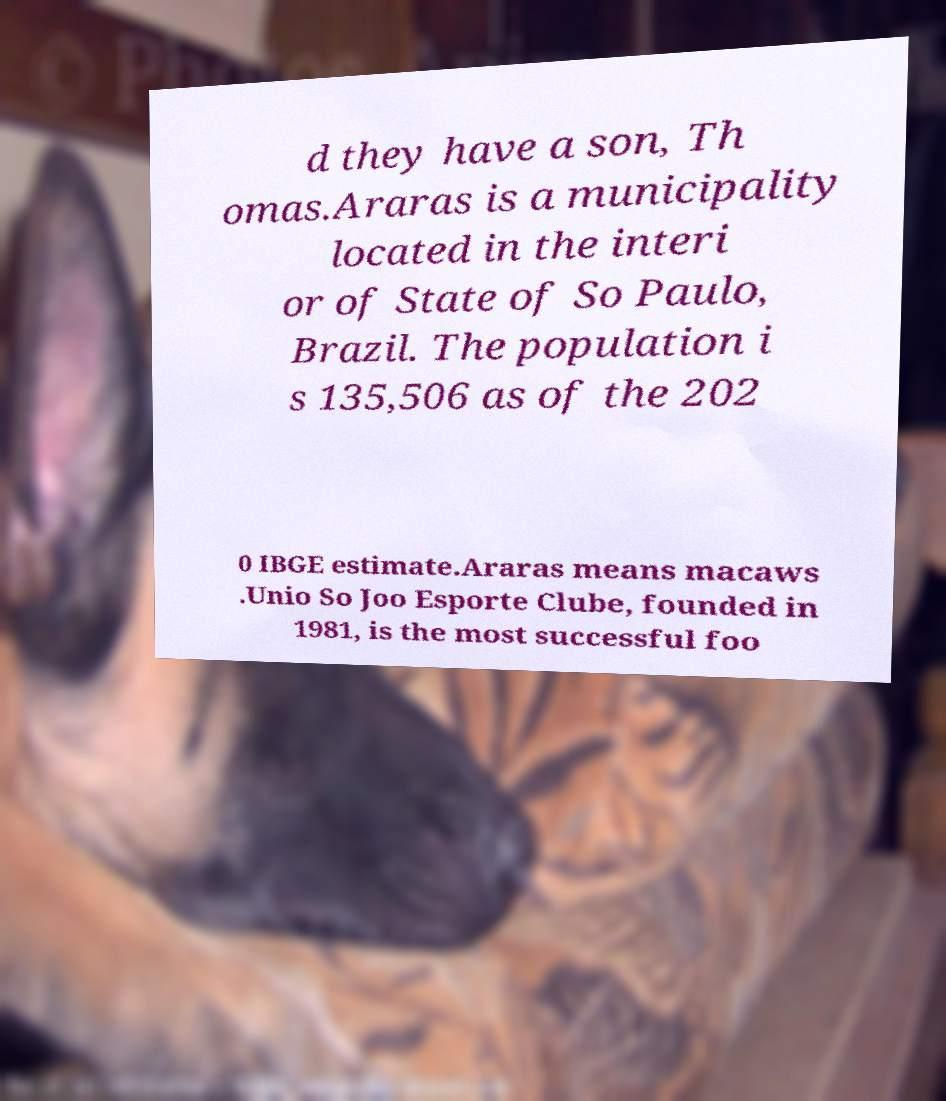Could you extract and type out the text from this image? d they have a son, Th omas.Araras is a municipality located in the interi or of State of So Paulo, Brazil. The population i s 135,506 as of the 202 0 IBGE estimate.Araras means macaws .Unio So Joo Esporte Clube, founded in 1981, is the most successful foo 